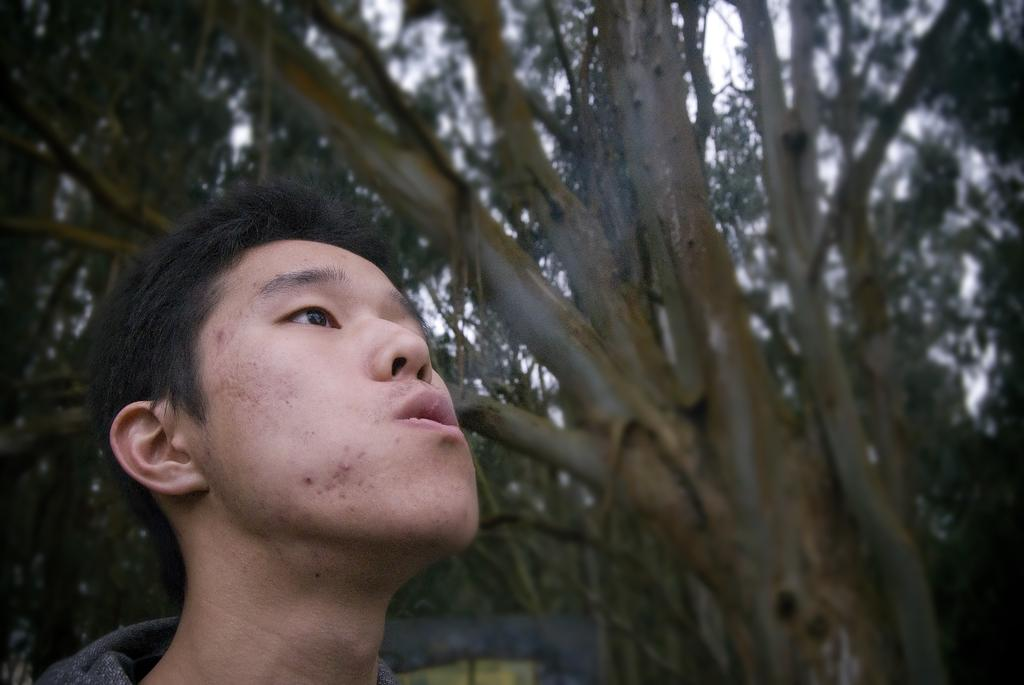Who is present in the image? There is a man in the image. What is the man doing in the image? The man is releasing smoke from his mouth. What can be seen in the background of the image? There are trees visible in the background of the image. What type of robin can be seen perched on the man's shoulder in the image? There is no robin present in the image; the man is releasing smoke from his mouth. How does the cat react to the smoke in the image? There is no cat present in the image, so it is not possible to determine how a cat might react to the smoke. 